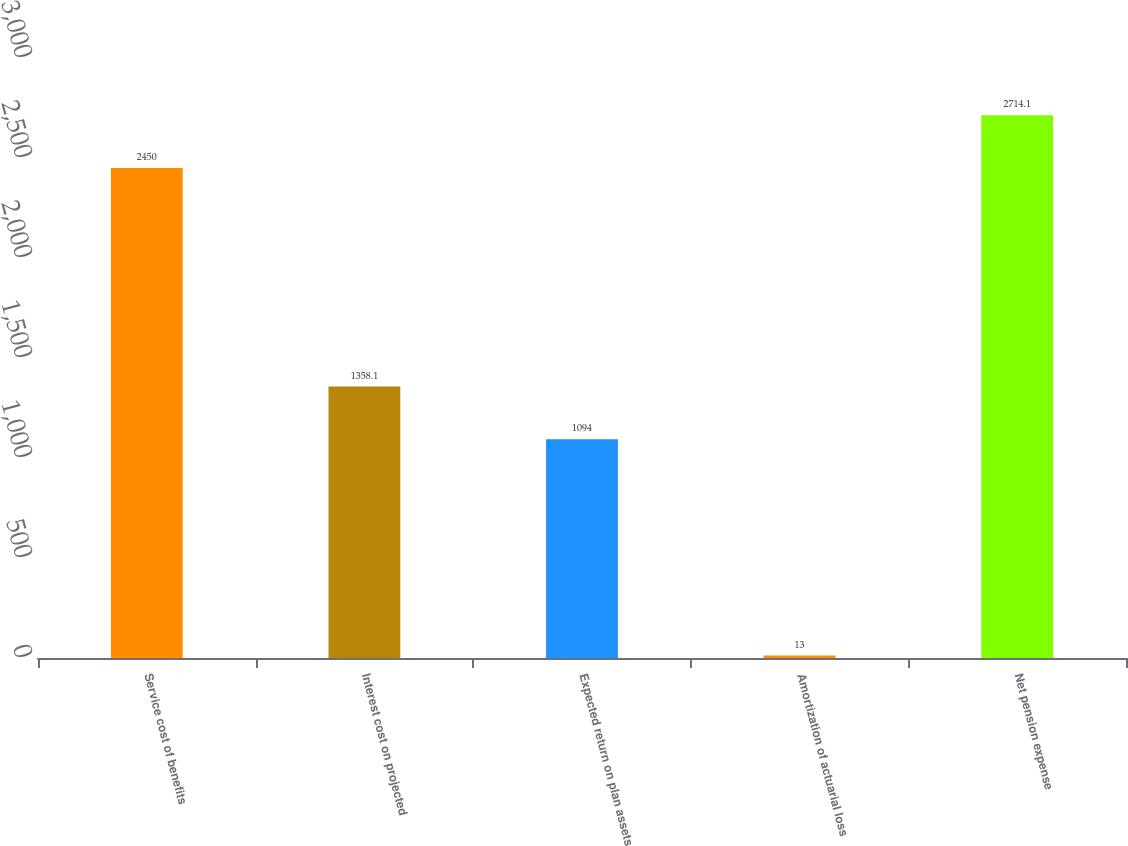Convert chart to OTSL. <chart><loc_0><loc_0><loc_500><loc_500><bar_chart><fcel>Service cost of benefits<fcel>Interest cost on projected<fcel>Expected return on plan assets<fcel>Amortization of actuarial loss<fcel>Net pension expense<nl><fcel>2450<fcel>1358.1<fcel>1094<fcel>13<fcel>2714.1<nl></chart> 